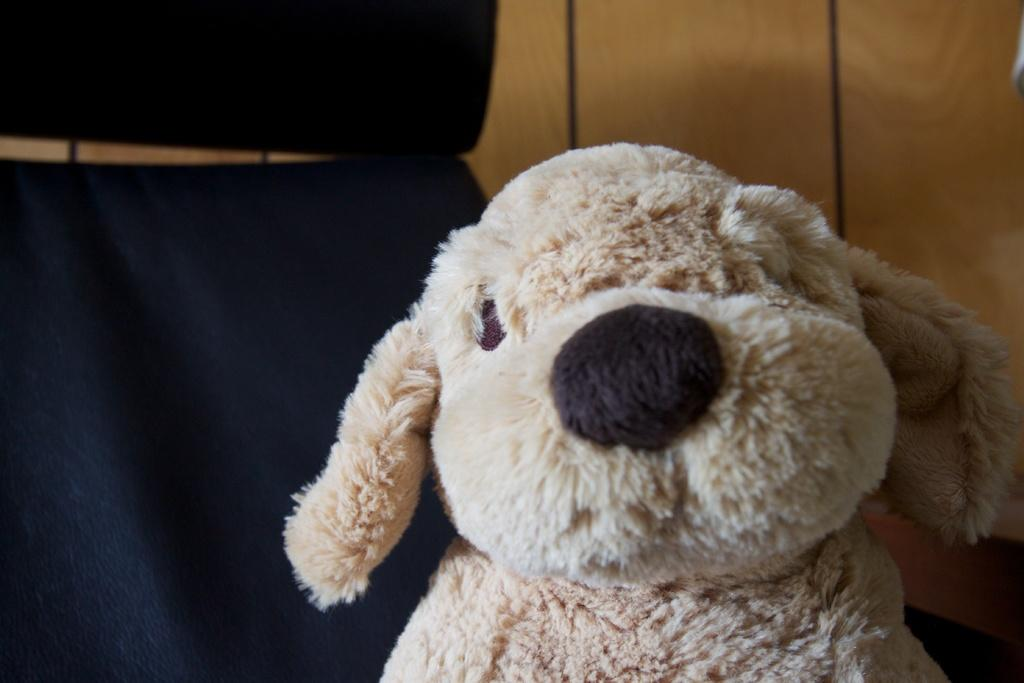What is located in the foreground of the image? There is a toy in the foreground of the image. What color is the object on the left side of the image? The object on the left side of the image is black. What type of object can be seen in the background of the image? There appears to be a wooden object in the background of the image. What is the name of the form that the wooden object takes in the image? There is no specific form mentioned in the image, and therefore no name can be assigned to it. 